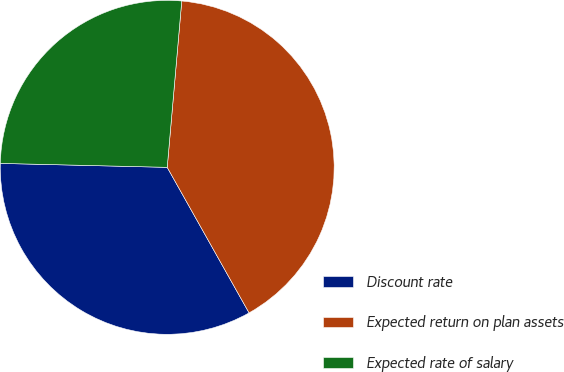Convert chart to OTSL. <chart><loc_0><loc_0><loc_500><loc_500><pie_chart><fcel>Discount rate<fcel>Expected return on plan assets<fcel>Expected rate of salary<nl><fcel>33.53%<fcel>40.46%<fcel>26.01%<nl></chart> 